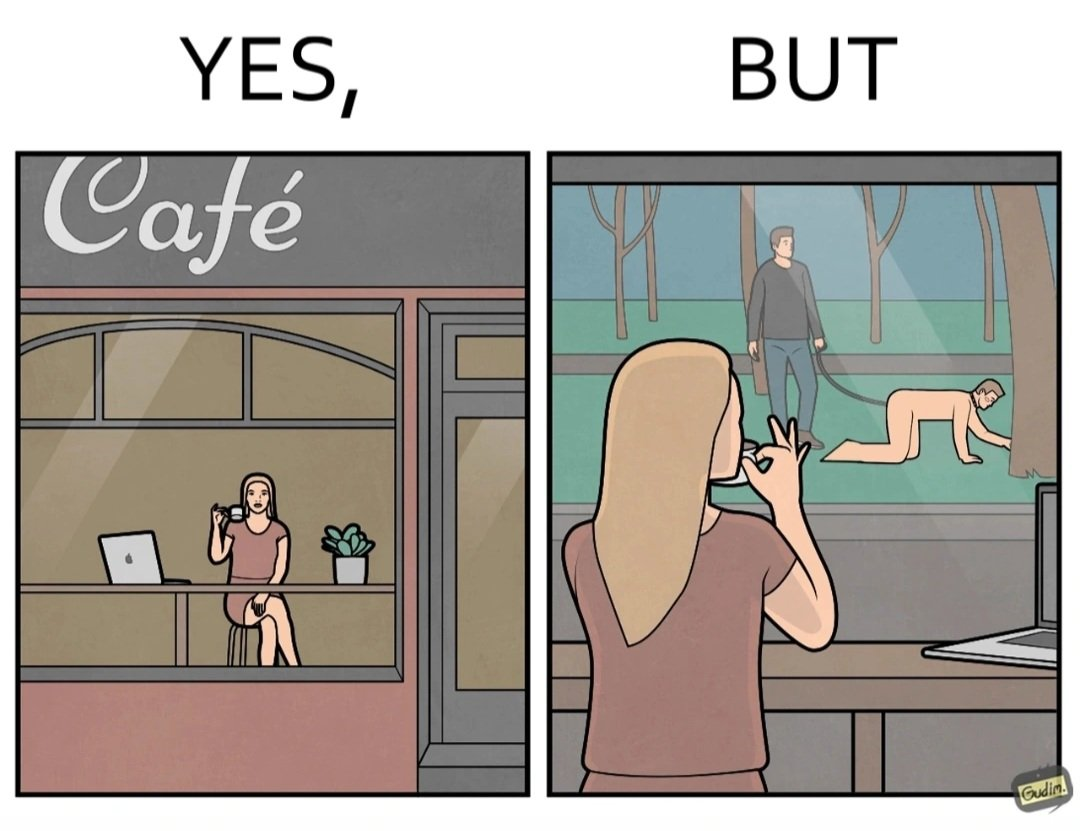Explain the humor or irony in this image. The image is ironic, because in the first image a woman is seen enjoying her coffee, while watching the injustice happening outside without even having a single thought on the injustice outside and taking some actions or raising some concerns over it 